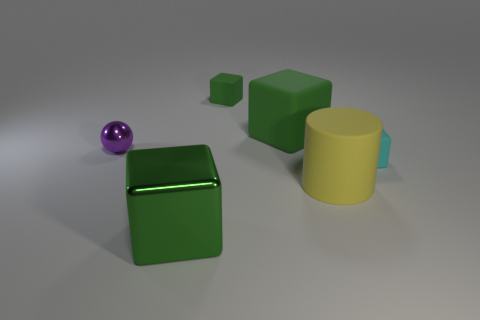Subtract all green blocks. How many were subtracted if there are1green blocks left? 2 Subtract all red balls. How many green cubes are left? 3 Subtract all purple blocks. Subtract all red cylinders. How many blocks are left? 4 Add 3 yellow things. How many objects exist? 9 Subtract all cylinders. How many objects are left? 5 Subtract all large green rubber objects. Subtract all big rubber things. How many objects are left? 3 Add 4 green matte cubes. How many green matte cubes are left? 6 Add 2 purple spheres. How many purple spheres exist? 3 Subtract 1 yellow cylinders. How many objects are left? 5 